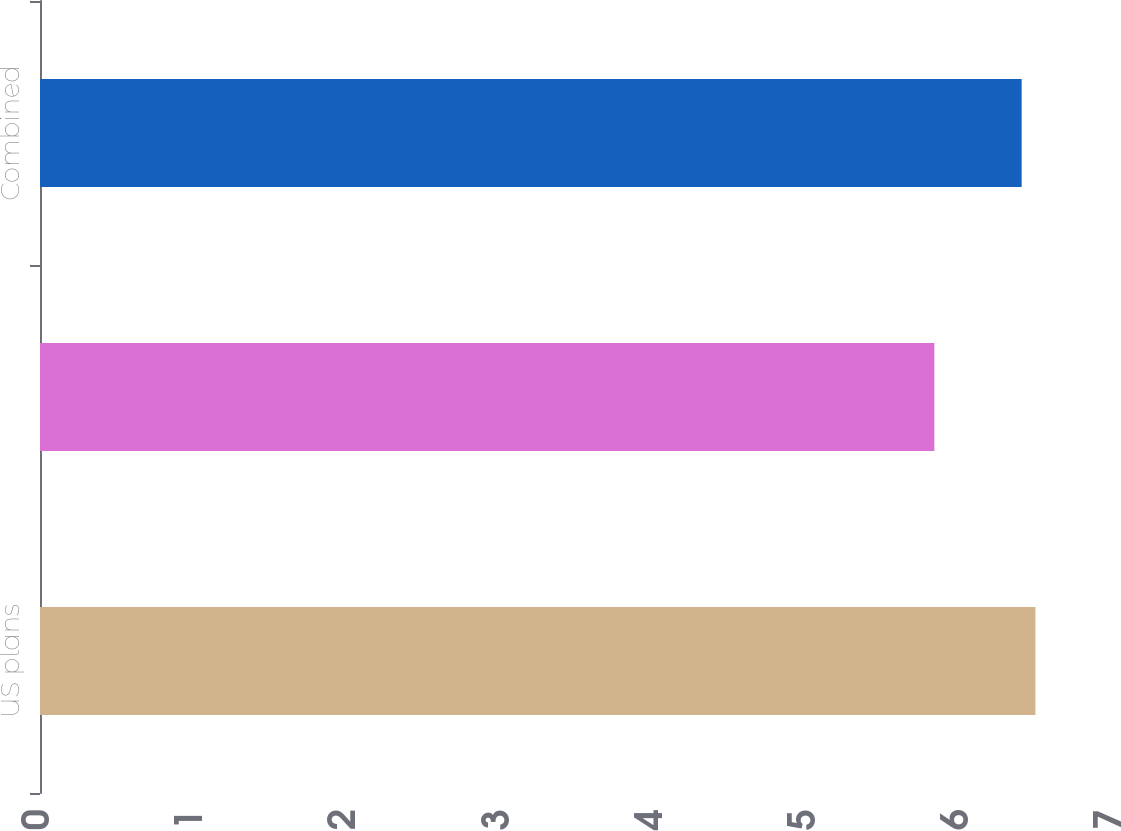Convert chart. <chart><loc_0><loc_0><loc_500><loc_500><bar_chart><fcel>US plans<fcel>International plans<fcel>Combined<nl><fcel>6.5<fcel>5.84<fcel>6.41<nl></chart> 